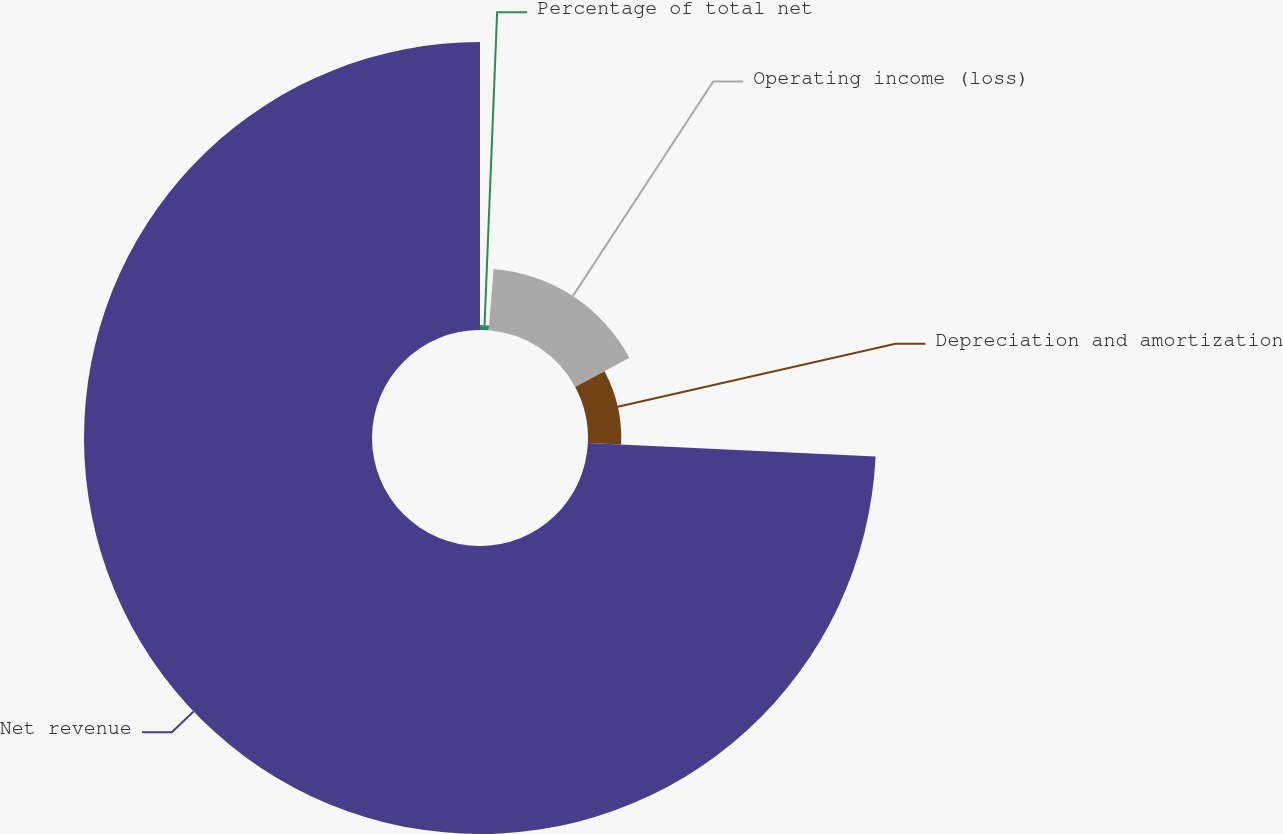Convert chart to OTSL. <chart><loc_0><loc_0><loc_500><loc_500><pie_chart><fcel>Percentage of total net<fcel>Operating income (loss)<fcel>Depreciation and amortization<fcel>Net revenue<nl><fcel>1.28%<fcel>15.88%<fcel>8.58%<fcel>74.26%<nl></chart> 